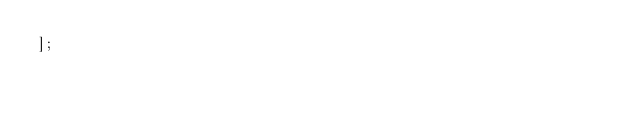Convert code to text. <code><loc_0><loc_0><loc_500><loc_500><_JavaScript_>];</code> 